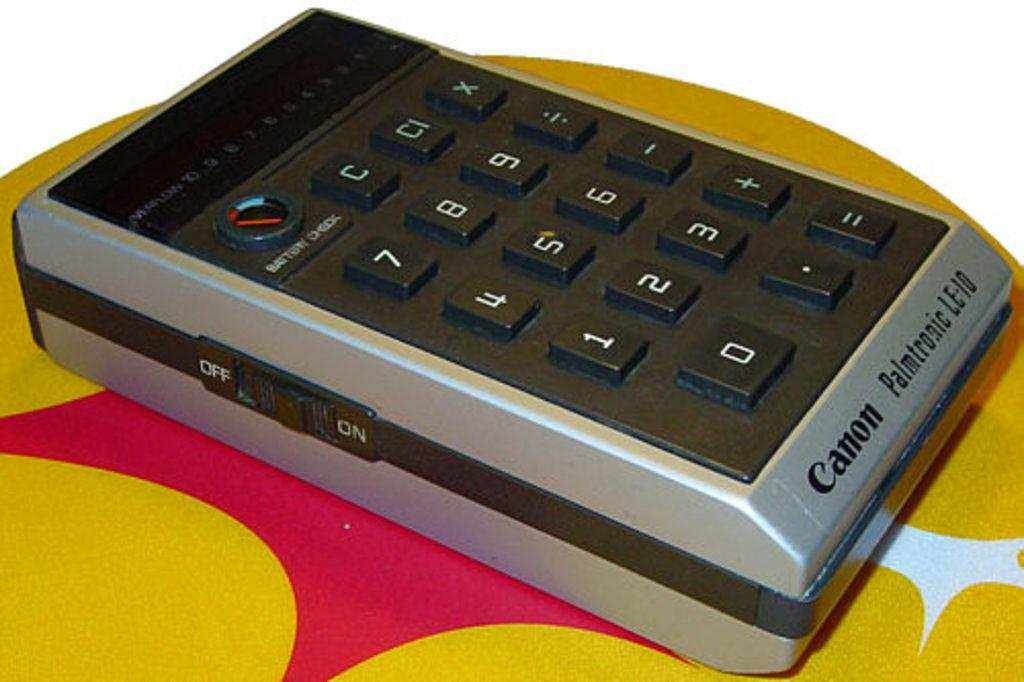Provide a one-sentence caption for the provided image. A very large calculator sits on a yellow and pink table with the word Canon written on the bottom of it. 